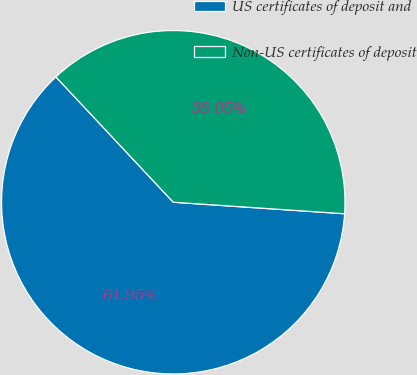Convert chart to OTSL. <chart><loc_0><loc_0><loc_500><loc_500><pie_chart><fcel>US certificates of deposit and<fcel>Non-US certificates of deposit<nl><fcel>61.95%<fcel>38.05%<nl></chart> 